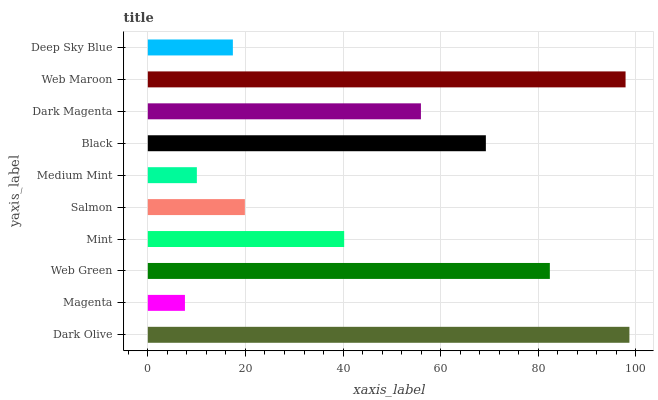Is Magenta the minimum?
Answer yes or no. Yes. Is Dark Olive the maximum?
Answer yes or no. Yes. Is Web Green the minimum?
Answer yes or no. No. Is Web Green the maximum?
Answer yes or no. No. Is Web Green greater than Magenta?
Answer yes or no. Yes. Is Magenta less than Web Green?
Answer yes or no. Yes. Is Magenta greater than Web Green?
Answer yes or no. No. Is Web Green less than Magenta?
Answer yes or no. No. Is Dark Magenta the high median?
Answer yes or no. Yes. Is Mint the low median?
Answer yes or no. Yes. Is Web Maroon the high median?
Answer yes or no. No. Is Black the low median?
Answer yes or no. No. 